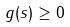<formula> <loc_0><loc_0><loc_500><loc_500>g ( s ) \geq 0</formula> 